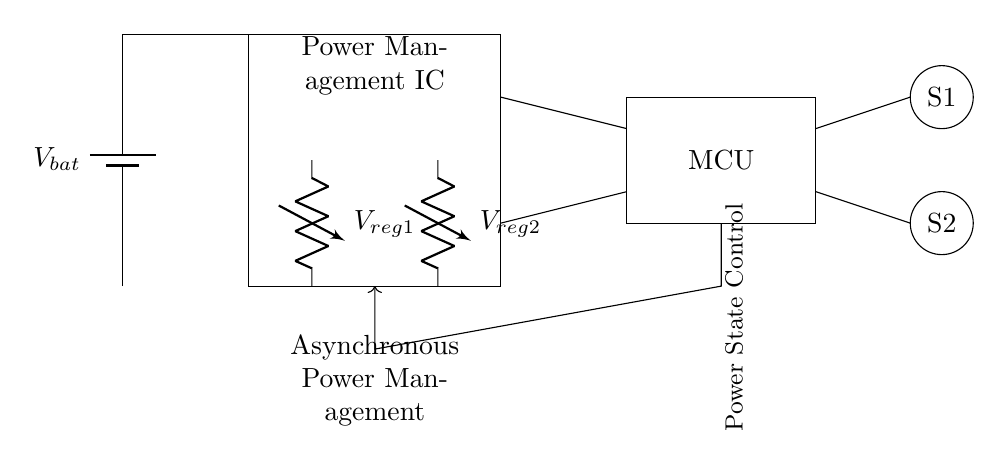What is the power source of this circuit? The circuit diagram indicates a battery labeled \( V_{bat} \) as the power source, which is shown at the left side of the circuit.
Answer: Battery What do \( V_{reg1} \) and \( V_{reg2} \) represent in this diagram? The voltage regulators \( V_{reg1} \) and \( V_{reg2} \) are components in the circuit that regulate the voltage levels. These can be found at the center with downward connections to the microcontroller.
Answer: Voltage regulators How many sensors are in the circuit? The diagram displays two sensors, labeled \( S1 \) and \( S2 \), each indicated by a circle on the right side of the circuit.
Answer: Two What is the connection type for the power state control? The power state control is represented by an arrow leading from the microcontroller downwards, indicating a directional connection used for managing power states effectively in an asynchronous manner.
Answer: Asynchronous control What does the label "Asynchronous Power Management" signify? This label shows that this circuit is designed to manage power states asynchronously, meaning it can change power states independently of the clock signal, located below the asynchronous control lines.
Answer: Power management What function does the microcontroller in this circuit serve? The microcontroller, labeled as "MCU" and positioned towards the right side, acts as the main control unit, managing inputs from sensors and regulating outputs based on power state requirements.
Answer: Main control unit 